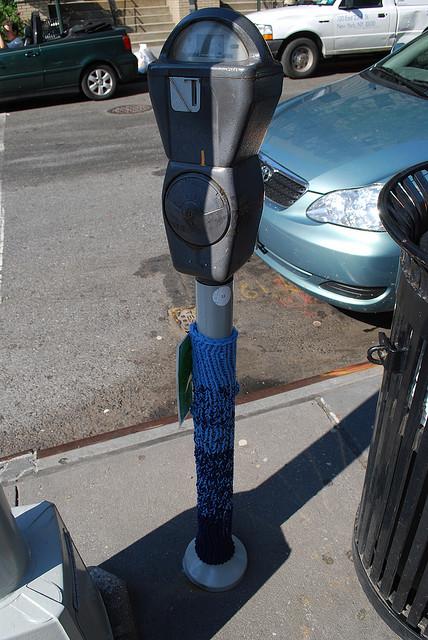What brand of car is the car on the left?
Keep it brief. Toyota. Is the car parked illegally?
Quick response, please. No. Can the car put money in the meter?
Quick response, please. No. What is next to the meter?
Write a very short answer. Trash can. What color is the car parked by the meter?
Write a very short answer. Blue. 